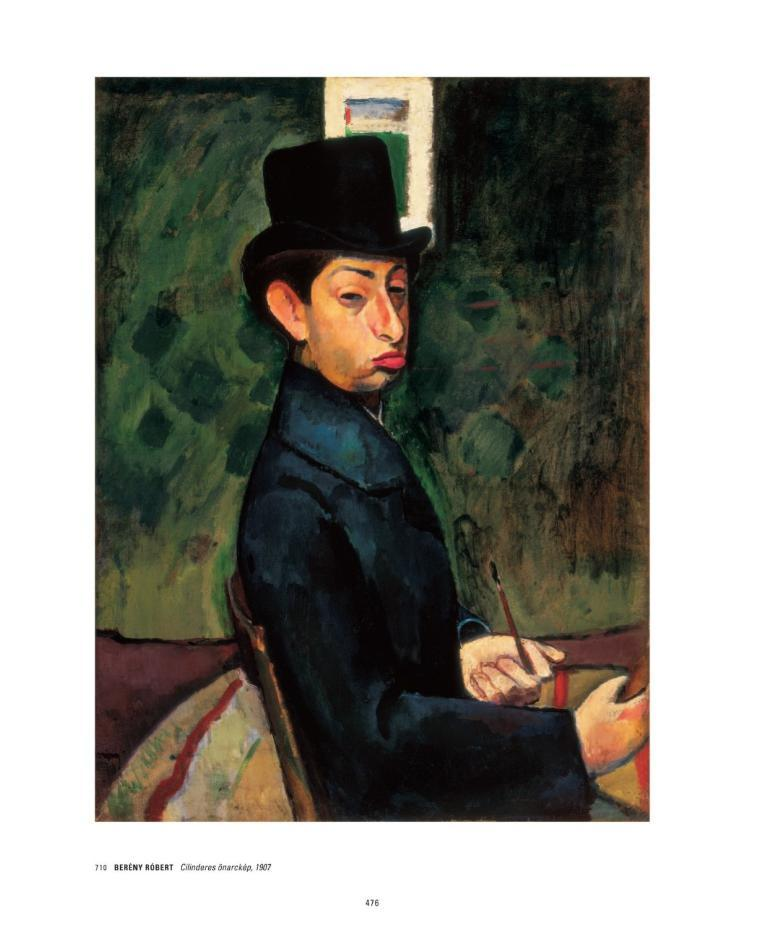What type of artwork is shown in the image? The image is a painting. Who or what is the subject of the painting? The painting depicts a person. What colors are used in the background of the painting? The background of the painting is green and black. What is the person in the painting wearing? The person in the painting is wearing a blue dress and a black cap. What type of humor can be found in the painting? There is no humor depicted in the painting; it is a straightforward portrait of a person. Is there a dock visible in the painting? There is no dock present in the painting; it focuses on the person and the green and black background. 